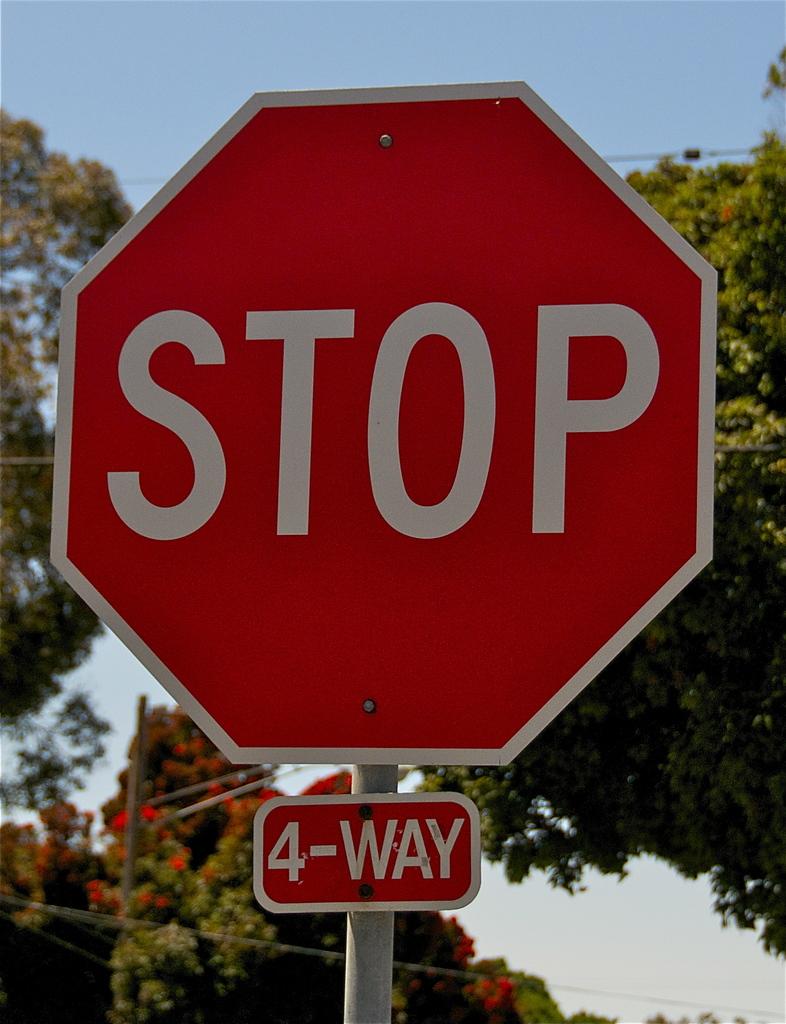What kind of stop is this?
Provide a succinct answer. 4-way. What is the title of the poster?
Provide a short and direct response. Unanswerable. 